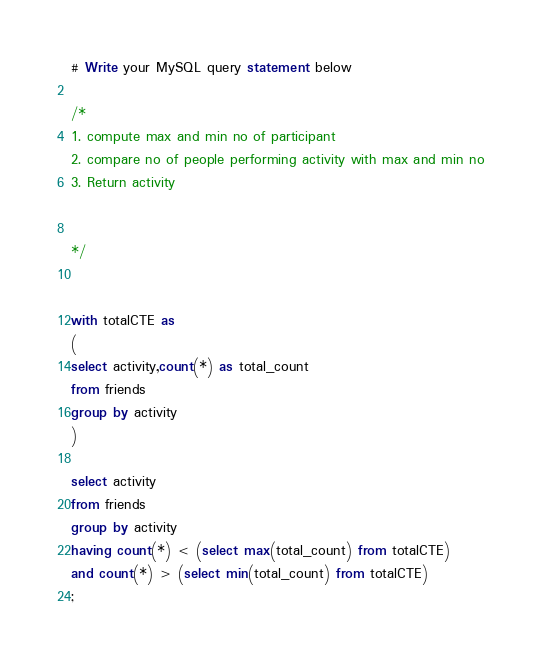<code> <loc_0><loc_0><loc_500><loc_500><_SQL_># Write your MySQL query statement below

/*
1. compute max and min no of participant
2. compare no of people performing activity with max and min no
3. Return activity


*/


with totalCTE as 
(
select activity,count(*) as total_count
from friends
group by activity
)

select activity
from friends
group by activity
having count(*) < (select max(total_count) from totalCTE)
and count(*) > (select min(total_count) from totalCTE)
;




</code> 